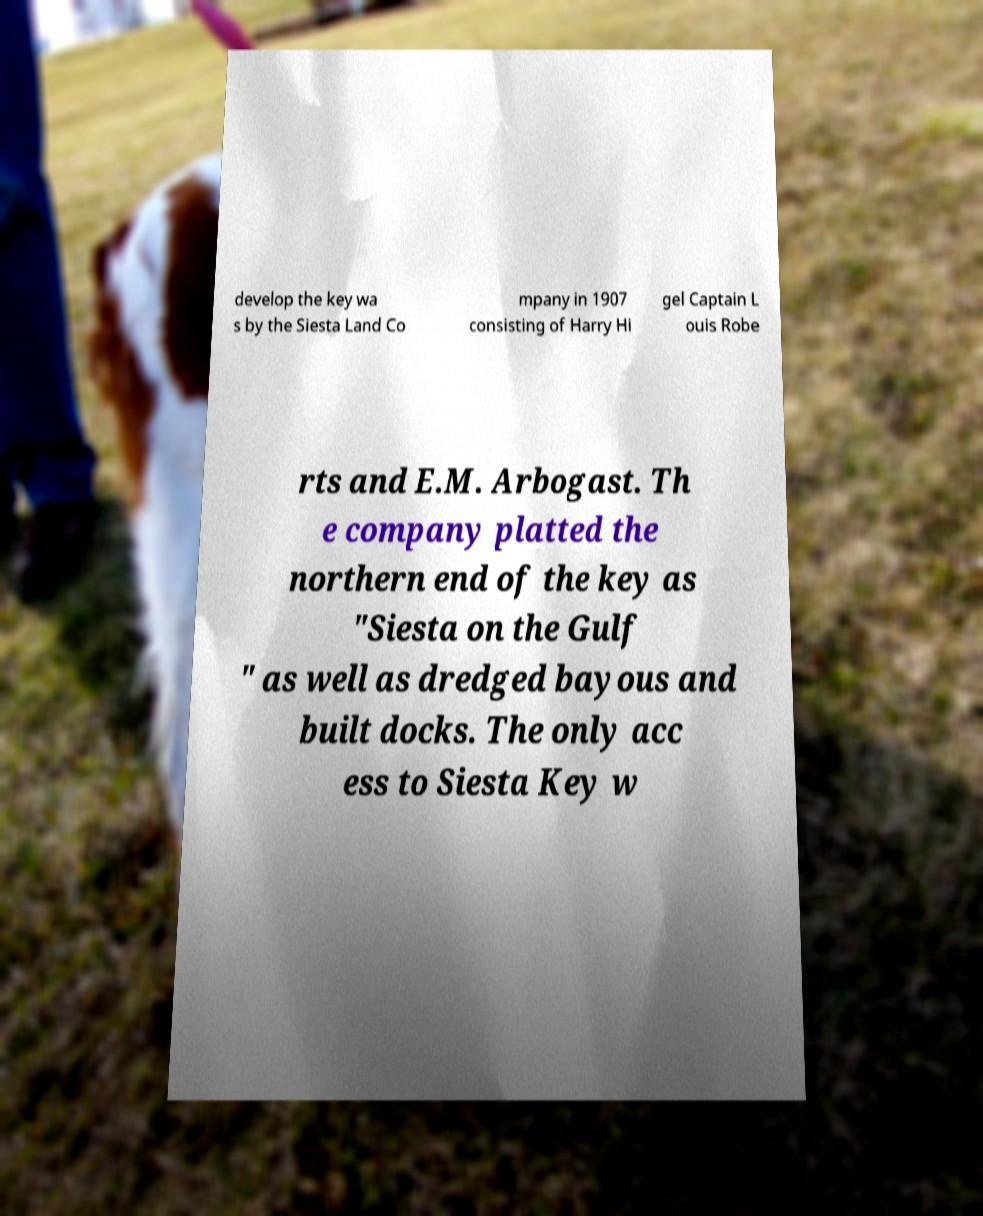Could you extract and type out the text from this image? develop the key wa s by the Siesta Land Co mpany in 1907 consisting of Harry Hi gel Captain L ouis Robe rts and E.M. Arbogast. Th e company platted the northern end of the key as "Siesta on the Gulf " as well as dredged bayous and built docks. The only acc ess to Siesta Key w 